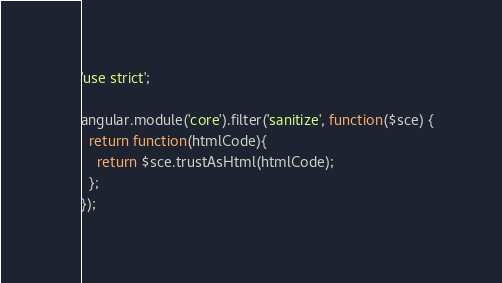Convert code to text. <code><loc_0><loc_0><loc_500><loc_500><_JavaScript_>'use strict';

angular.module('core').filter('sanitize', function($sce) {
  return function(htmlCode){
    return $sce.trustAsHtml(htmlCode);
  };
});</code> 